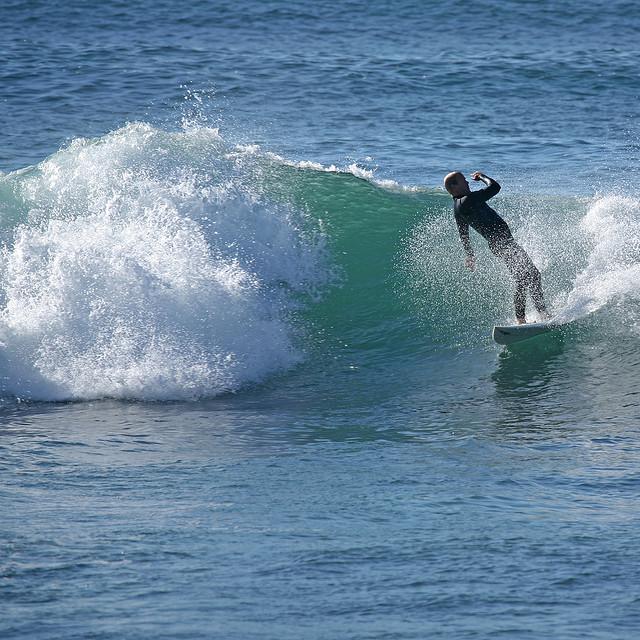Is the picture in black and white?
Be succinct. No. How  many people are surfing?
Be succinct. 1. Are the waves huge?
Concise answer only. No. Is there anyone in the water?
Short answer required. Yes. Is somebody about to fall?
Quick response, please. Yes. What is the man standing on?
Give a very brief answer. Surfboard. How many boys are there in the sea?
Answer briefly. 1. What type of body of water is this?
Concise answer only. Ocean. Is it likely the photographer appreciated the contrasting shades and shapes depicted?
Keep it brief. Yes. Is this on the beach?
Keep it brief. Yes. How many people are surfing?
Answer briefly. 1. Will the man fall off the board?
Answer briefly. Yes. Is this man in the process of falling off of the surfboard?
Quick response, please. No. Is the water calm?
Give a very brief answer. No. Are the water calm in the sea?
Concise answer only. No. How many surfers are in this photo?
Concise answer only. 1. Is the person actively surfing at this moment?
Answer briefly. Yes. Has the man fallen off the surfboard in the picture?
Quick response, please. No. How many people are in the water?
Keep it brief. 1. 